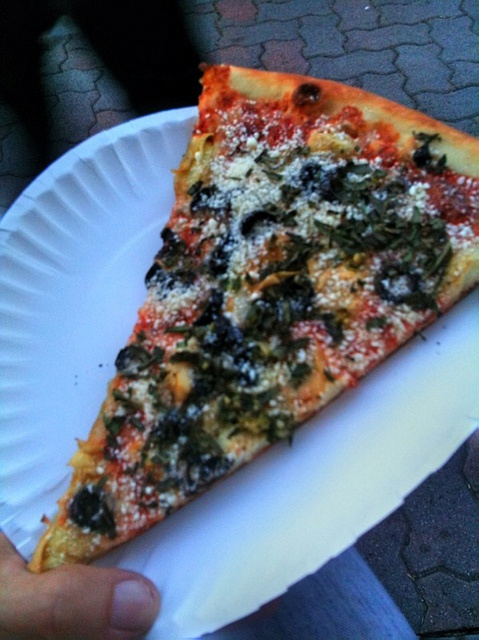Describe the objects in this image and their specific colors. I can see pizza in black, gray, and darkgray tones and people in black and gray tones in this image. 